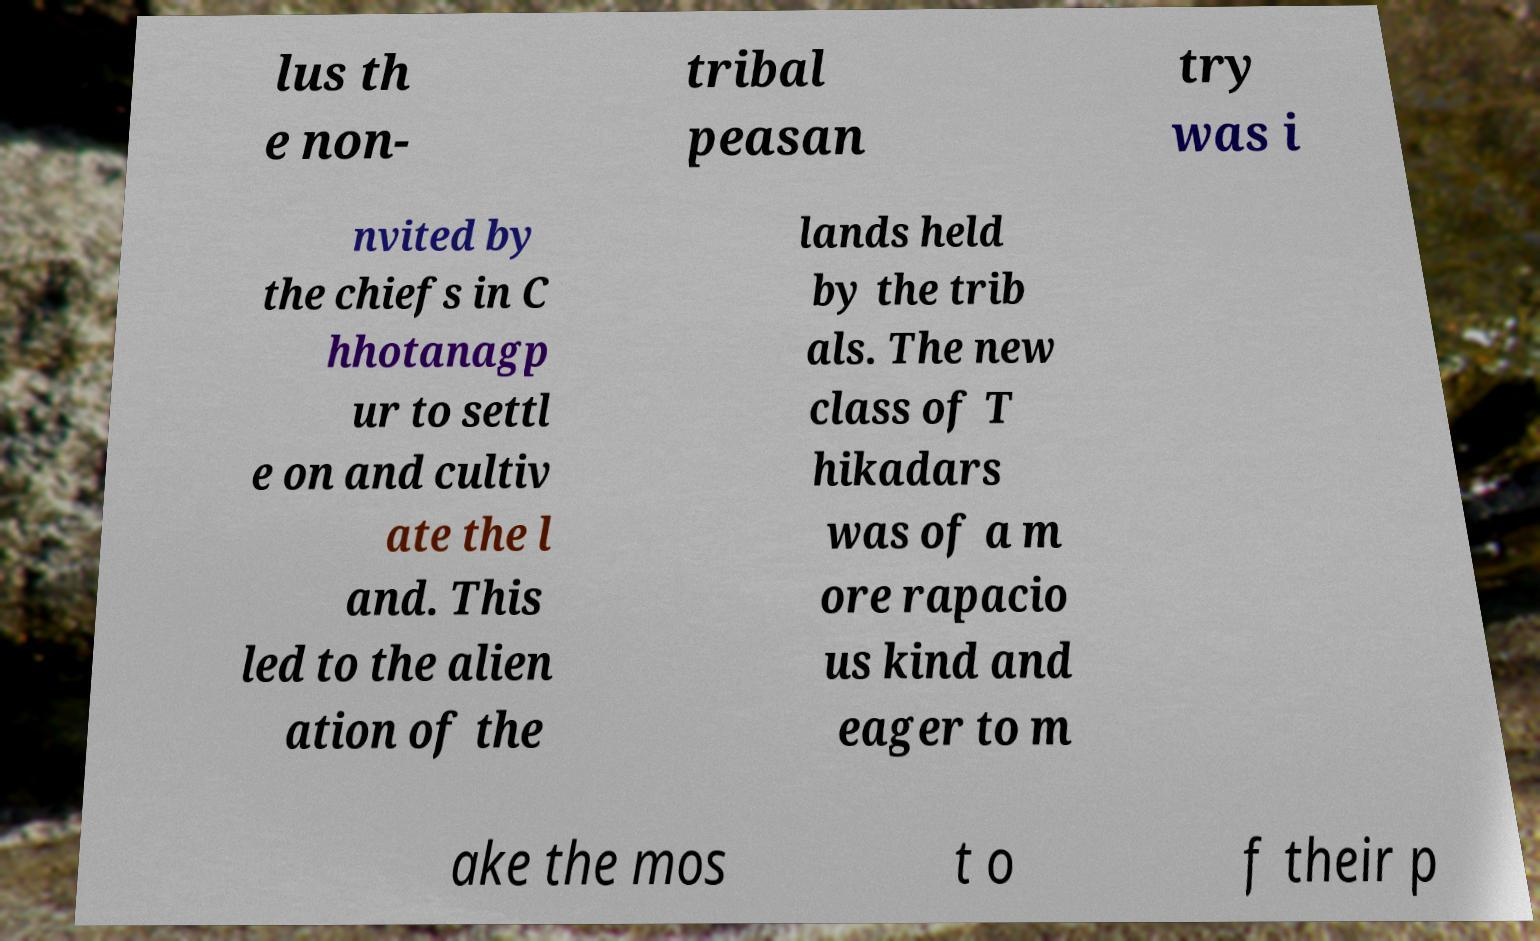What messages or text are displayed in this image? I need them in a readable, typed format. lus th e non- tribal peasan try was i nvited by the chiefs in C hhotanagp ur to settl e on and cultiv ate the l and. This led to the alien ation of the lands held by the trib als. The new class of T hikadars was of a m ore rapacio us kind and eager to m ake the mos t o f their p 